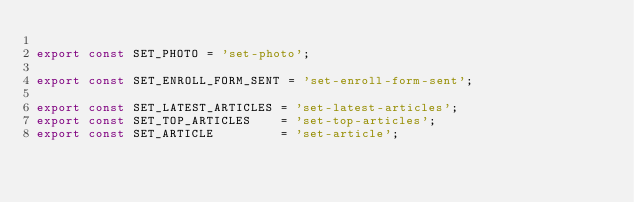<code> <loc_0><loc_0><loc_500><loc_500><_JavaScript_>
export const SET_PHOTO = 'set-photo';

export const SET_ENROLL_FORM_SENT = 'set-enroll-form-sent';

export const SET_LATEST_ARTICLES = 'set-latest-articles';
export const SET_TOP_ARTICLES    = 'set-top-articles';
export const SET_ARTICLE         = 'set-article';
</code> 